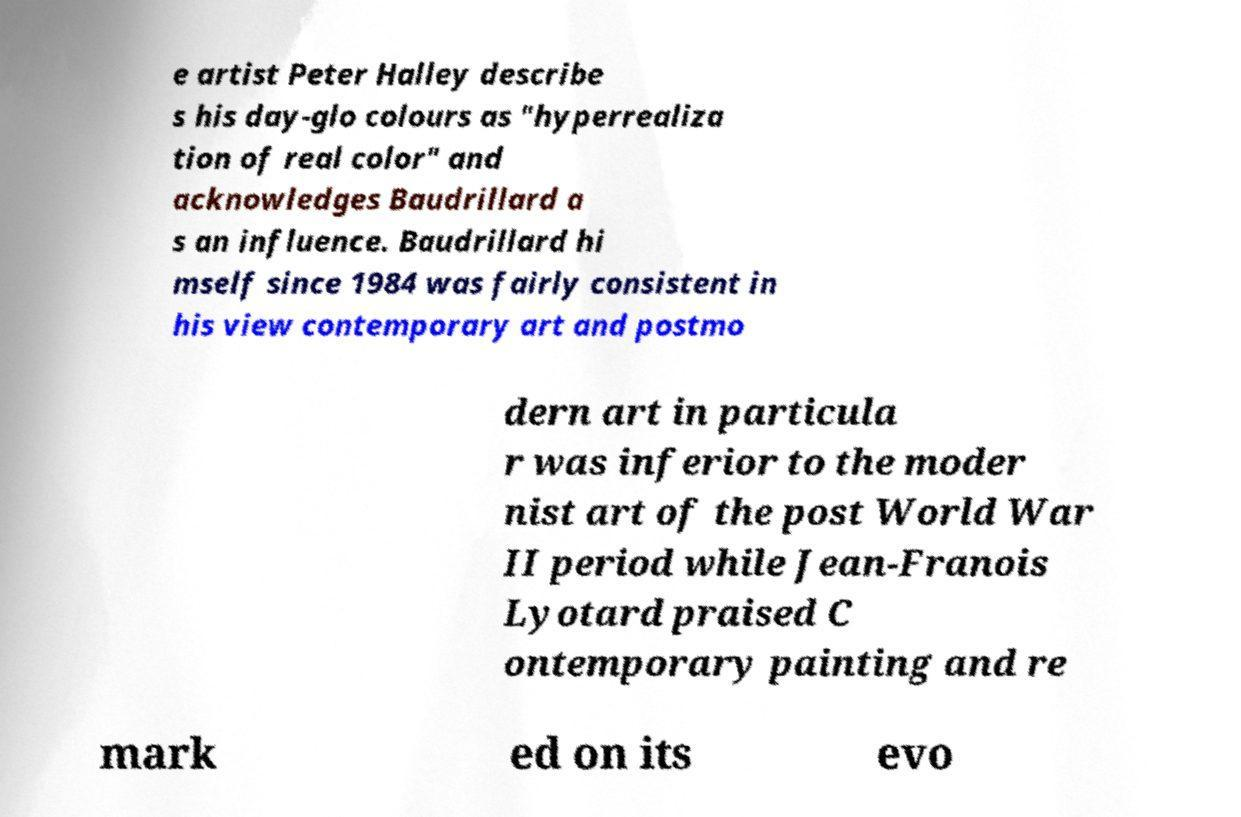Please identify and transcribe the text found in this image. e artist Peter Halley describe s his day-glo colours as "hyperrealiza tion of real color" and acknowledges Baudrillard a s an influence. Baudrillard hi mself since 1984 was fairly consistent in his view contemporary art and postmo dern art in particula r was inferior to the moder nist art of the post World War II period while Jean-Franois Lyotard praised C ontemporary painting and re mark ed on its evo 